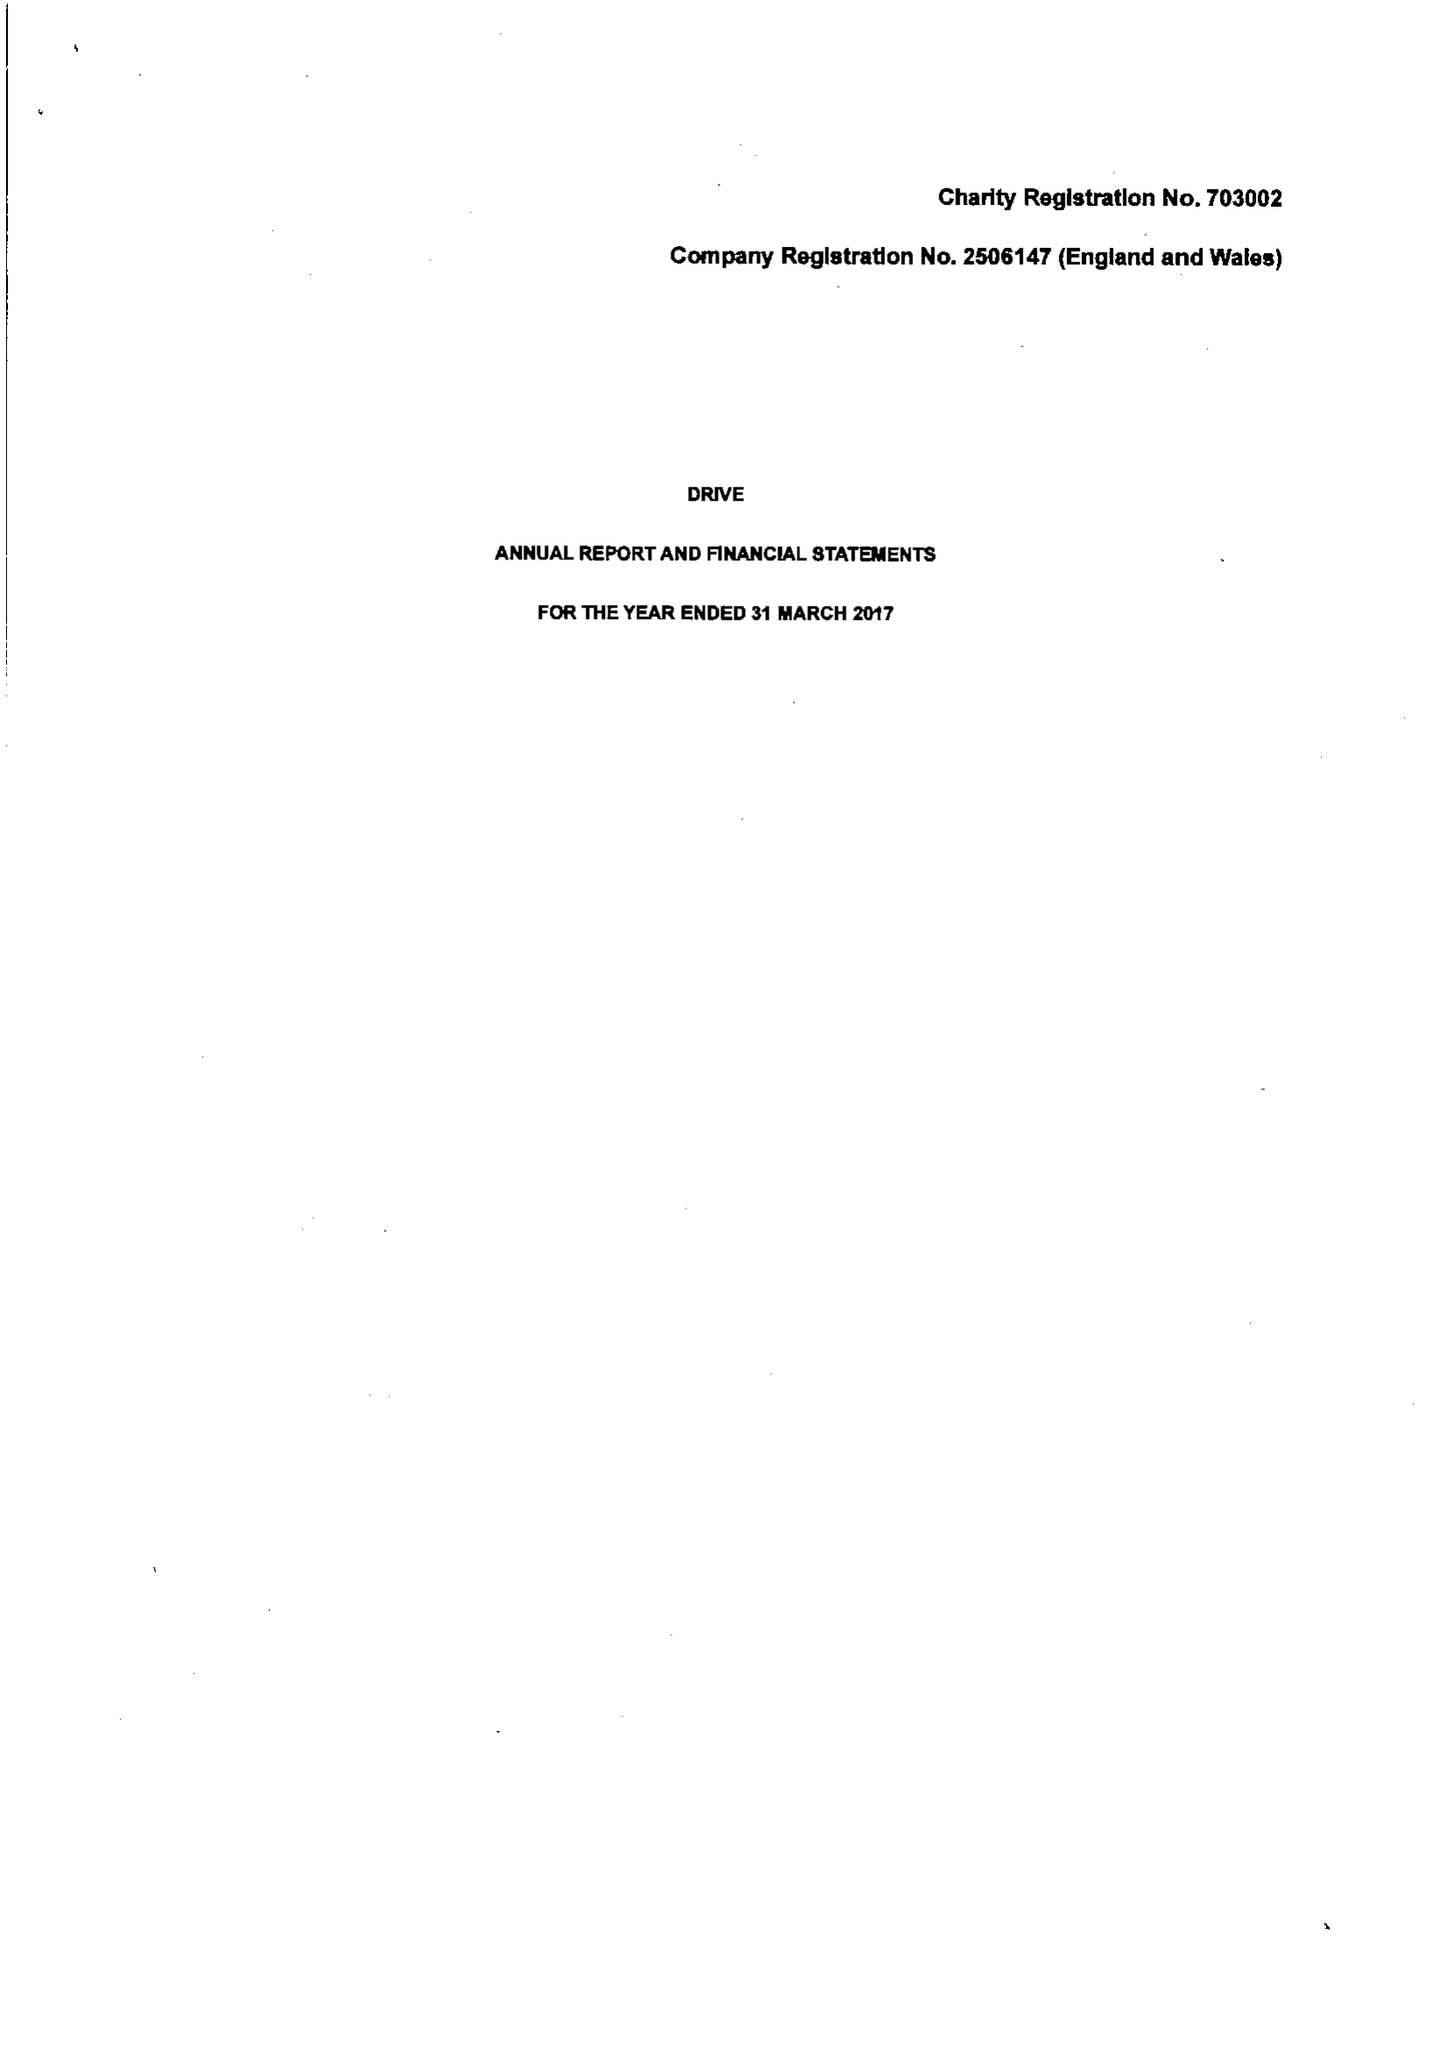What is the value for the address__postcode?
Answer the question using a single word or phrase. CF15 7QQ 